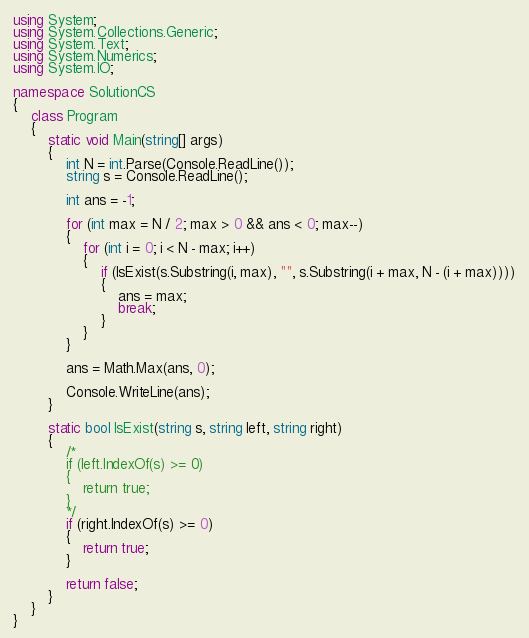Convert code to text. <code><loc_0><loc_0><loc_500><loc_500><_C#_>using System;
using System.Collections.Generic;
using System.Text;
using System.Numerics;
using System.IO;

namespace SolutionCS
{
    class Program
    {
        static void Main(string[] args)
        {
            int N = int.Parse(Console.ReadLine());
            string s = Console.ReadLine();

            int ans = -1;

            for (int max = N / 2; max > 0 && ans < 0; max--)
            {
                for (int i = 0; i < N - max; i++)
                {
                    if (IsExist(s.Substring(i, max), "", s.Substring(i + max, N - (i + max))))
                    {
                        ans = max;
                        break;
                    }
                }
            }

            ans = Math.Max(ans, 0);

            Console.WriteLine(ans);
        }

        static bool IsExist(string s, string left, string right)
        {
            /*
            if (left.IndexOf(s) >= 0)
            {
                return true;
            }
            */
            if (right.IndexOf(s) >= 0)
            {
                return true;
            }

            return false;
        }
    }
}

</code> 